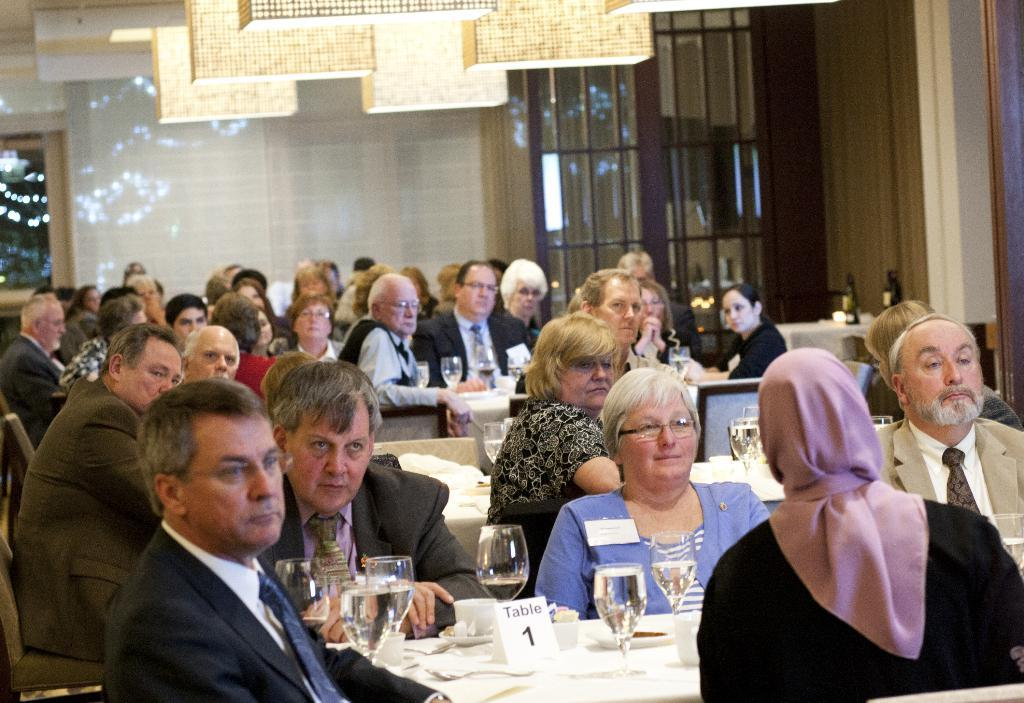How many people are in the image? There are many people in the image. What are the people doing in the image? The people are sitting in front of a table. What can be seen on the table in the image? There are many glasses on the table. What type of machine is being used by the family in the image? There is no machine present in the image, nor is there any indication that the people in the image are a family. 